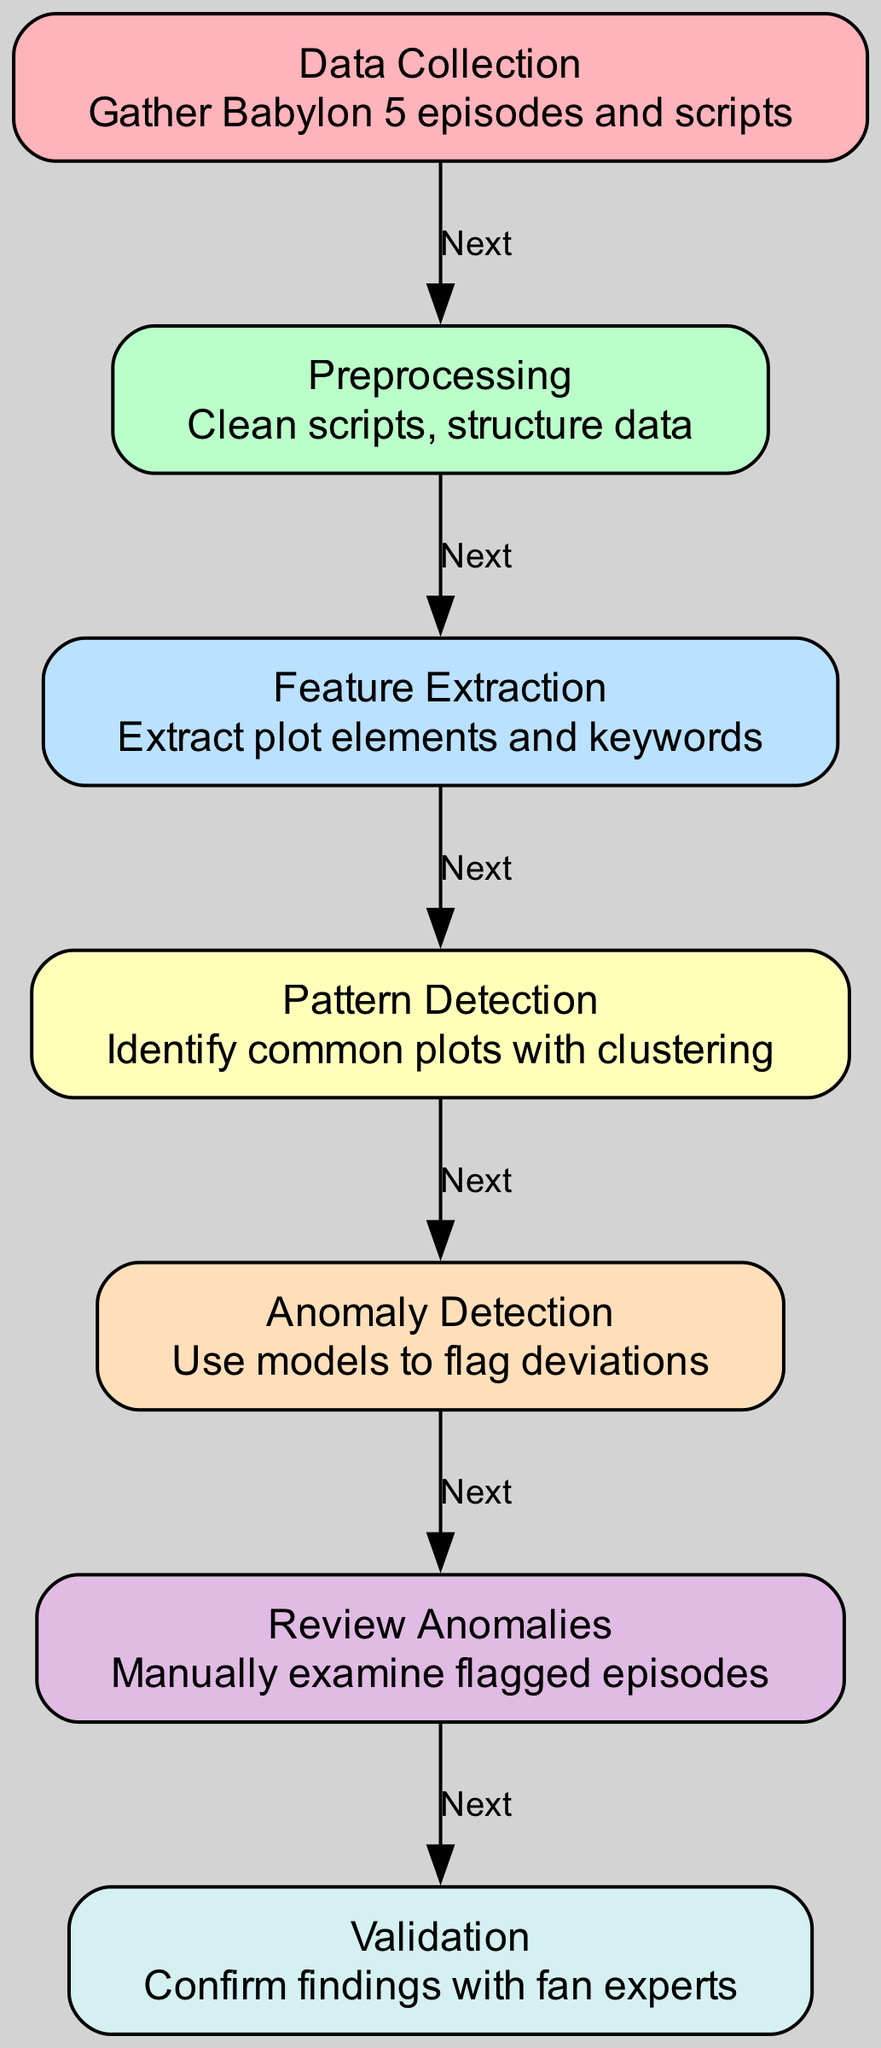What is the label of the first node? The first node in the diagram is labeled "Data Collection". This can be determined by looking at the top of the node list in the diagram.
Answer: Data Collection How many nodes are there in total? The diagram contains seven nodes as listed in the provided data. You can count them to confirm.
Answer: Seven What is the last step before validation? By examining the edges, the last step that connects to the validation node is "Review Anomalies". This indicates the last process before the final validation.
Answer: Review Anomalies Which nodes directly connect to "Pattern Detection"? The node that directly connects to "Pattern Detection" is "Feature Extraction". This can be seen by following the directed edge from Feature Extraction to Pattern Detection.
Answer: Feature Extraction What type of data is gathered in the first step? The first step involves gathering "Babylon 5 episodes and scripts," which is described in the node labeled "Data Collection."
Answer: Babylon 5 episodes and scripts What is the purpose of the "Anomaly Detection" node? The "Anomaly Detection" node's purpose is to "Use models to flag deviations," as per its description in the diagram. This indicates it is focused on identifying unusual plotlines.
Answer: Use models to flag deviations How are episodes examined after being flagged? The flagged episodes are examined in the "Review Anomalies" step, where they are manually scrutinized. This is indicated in the corresponding node's description.
Answer: Manually examine flagged episodes Which process is necessary to structure the data? The "Preprocessing" step is necessary to clean scripts and structure data, and this is highlighted in its description in the diagram.
Answer: Preprocessing What connection is indicated by the edge from "Pattern Detection" to "Anomaly Detection"? The edge indicates that after identifying common plots, the next logical step is to carry out "Anomaly Detection," suggesting a flow from plot identification to deviation analysis.
Answer: Anomaly Detection 